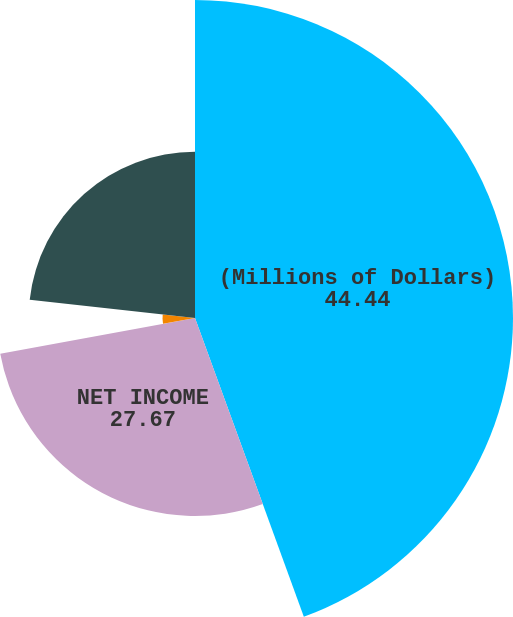Convert chart. <chart><loc_0><loc_0><loc_500><loc_500><pie_chart><fcel>(Millions of Dollars)<fcel>NET INCOME<fcel>Pension and other<fcel>TOTAL OTHER COMPREHENSIVE<fcel>COMPREHENSIVE INCOME<nl><fcel>44.44%<fcel>27.67%<fcel>0.11%<fcel>4.54%<fcel>23.24%<nl></chart> 